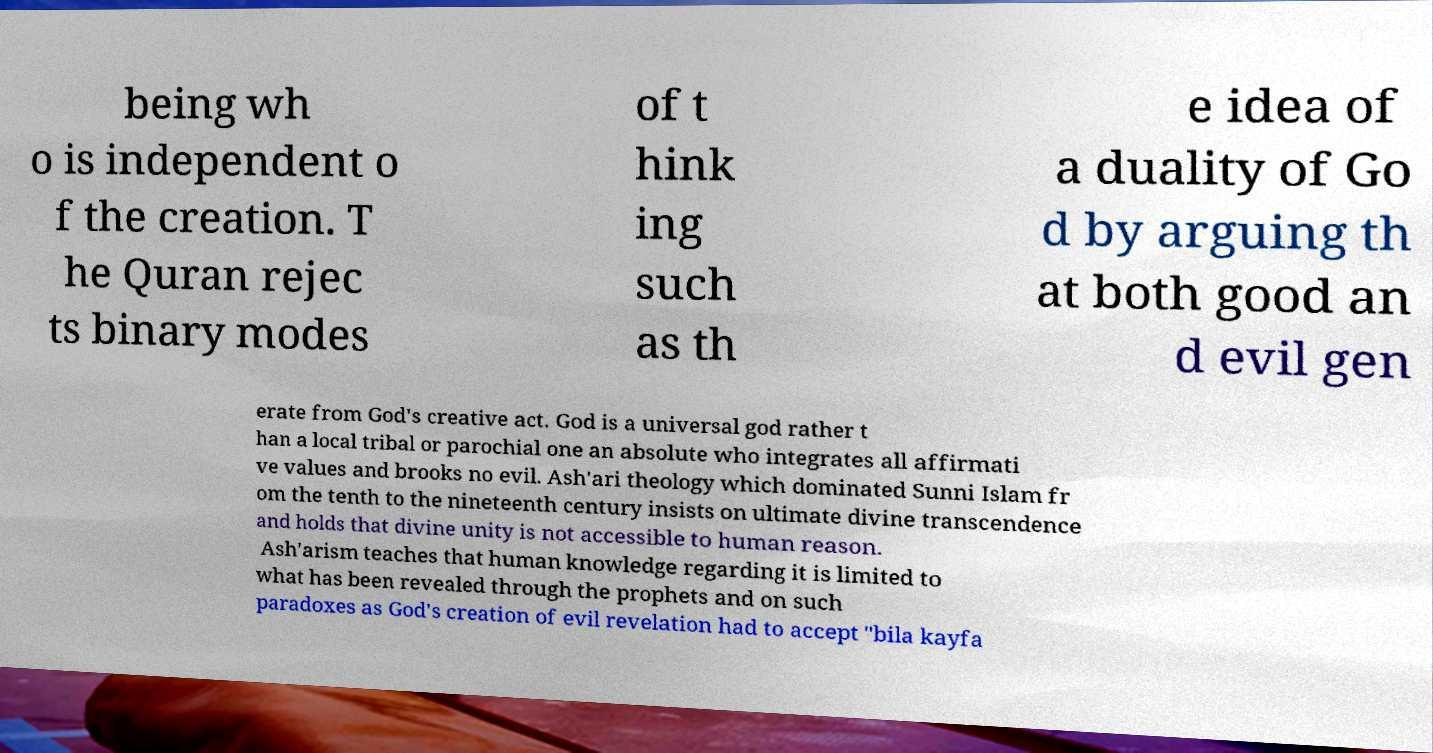For documentation purposes, I need the text within this image transcribed. Could you provide that? being wh o is independent o f the creation. T he Quran rejec ts binary modes of t hink ing such as th e idea of a duality of Go d by arguing th at both good an d evil gen erate from God's creative act. God is a universal god rather t han a local tribal or parochial one an absolute who integrates all affirmati ve values and brooks no evil. Ash'ari theology which dominated Sunni Islam fr om the tenth to the nineteenth century insists on ultimate divine transcendence and holds that divine unity is not accessible to human reason. Ash'arism teaches that human knowledge regarding it is limited to what has been revealed through the prophets and on such paradoxes as God's creation of evil revelation had to accept "bila kayfa 